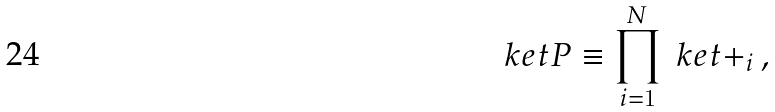<formula> <loc_0><loc_0><loc_500><loc_500>\ k e t { P } \equiv \prod _ { i = 1 } ^ { N } \ k e t { + } _ { i } \, ,</formula> 